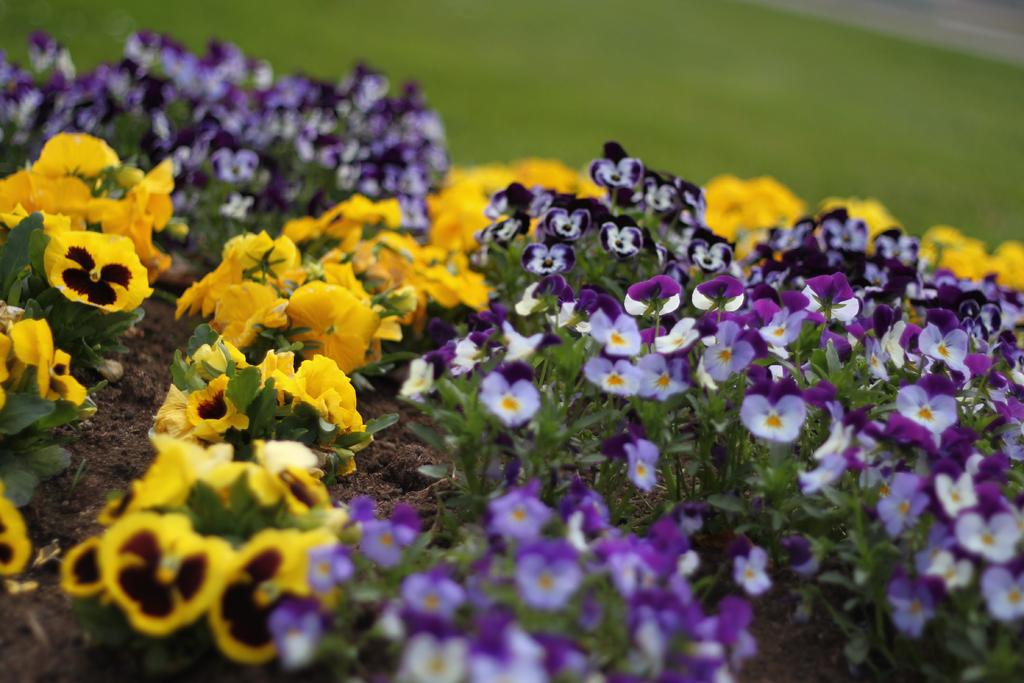What type of plants can be seen in the image? There are plants with flowers in the image. What can be seen in the background of the image? There is grass in the background of the image. How would you describe the clarity of the image? The image is blurry. What type of lumber is being used to support the plants in the image? There is no lumber visible in the image; the plants are not supported by any visible structures. 